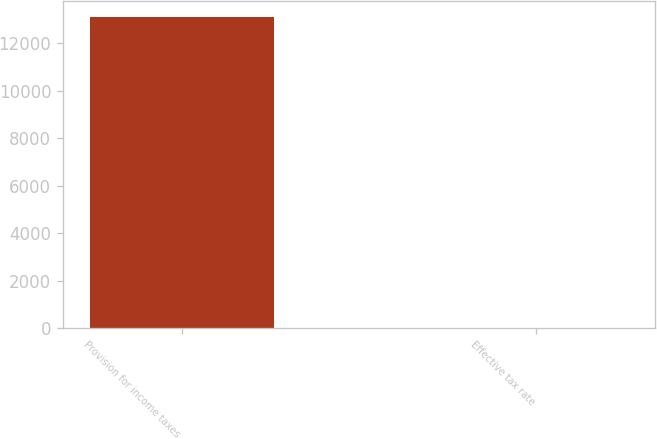<chart> <loc_0><loc_0><loc_500><loc_500><bar_chart><fcel>Provision for income taxes<fcel>Effective tax rate<nl><fcel>13118<fcel>26.2<nl></chart> 